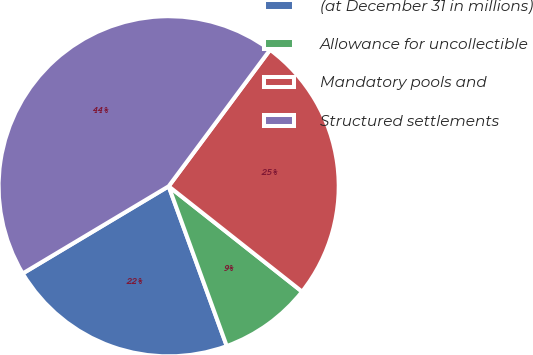Convert chart to OTSL. <chart><loc_0><loc_0><loc_500><loc_500><pie_chart><fcel>(at December 31 in millions)<fcel>Allowance for uncollectible<fcel>Mandatory pools and<fcel>Structured settlements<nl><fcel>21.98%<fcel>8.81%<fcel>25.47%<fcel>43.74%<nl></chart> 